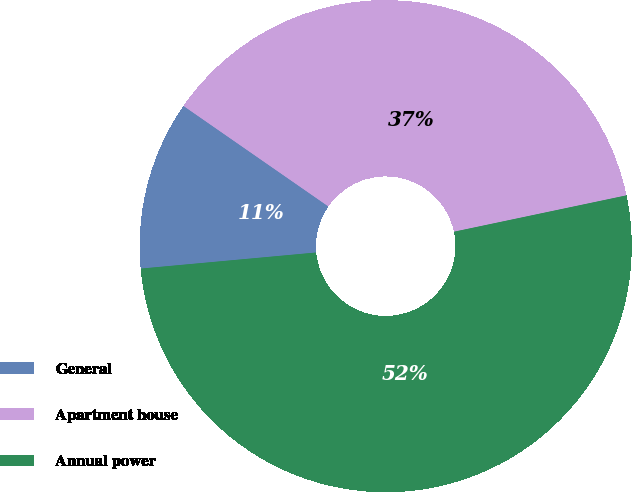Convert chart to OTSL. <chart><loc_0><loc_0><loc_500><loc_500><pie_chart><fcel>General<fcel>Apartment house<fcel>Annual power<nl><fcel>11.11%<fcel>37.04%<fcel>51.85%<nl></chart> 